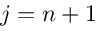<formula> <loc_0><loc_0><loc_500><loc_500>j = n + 1</formula> 